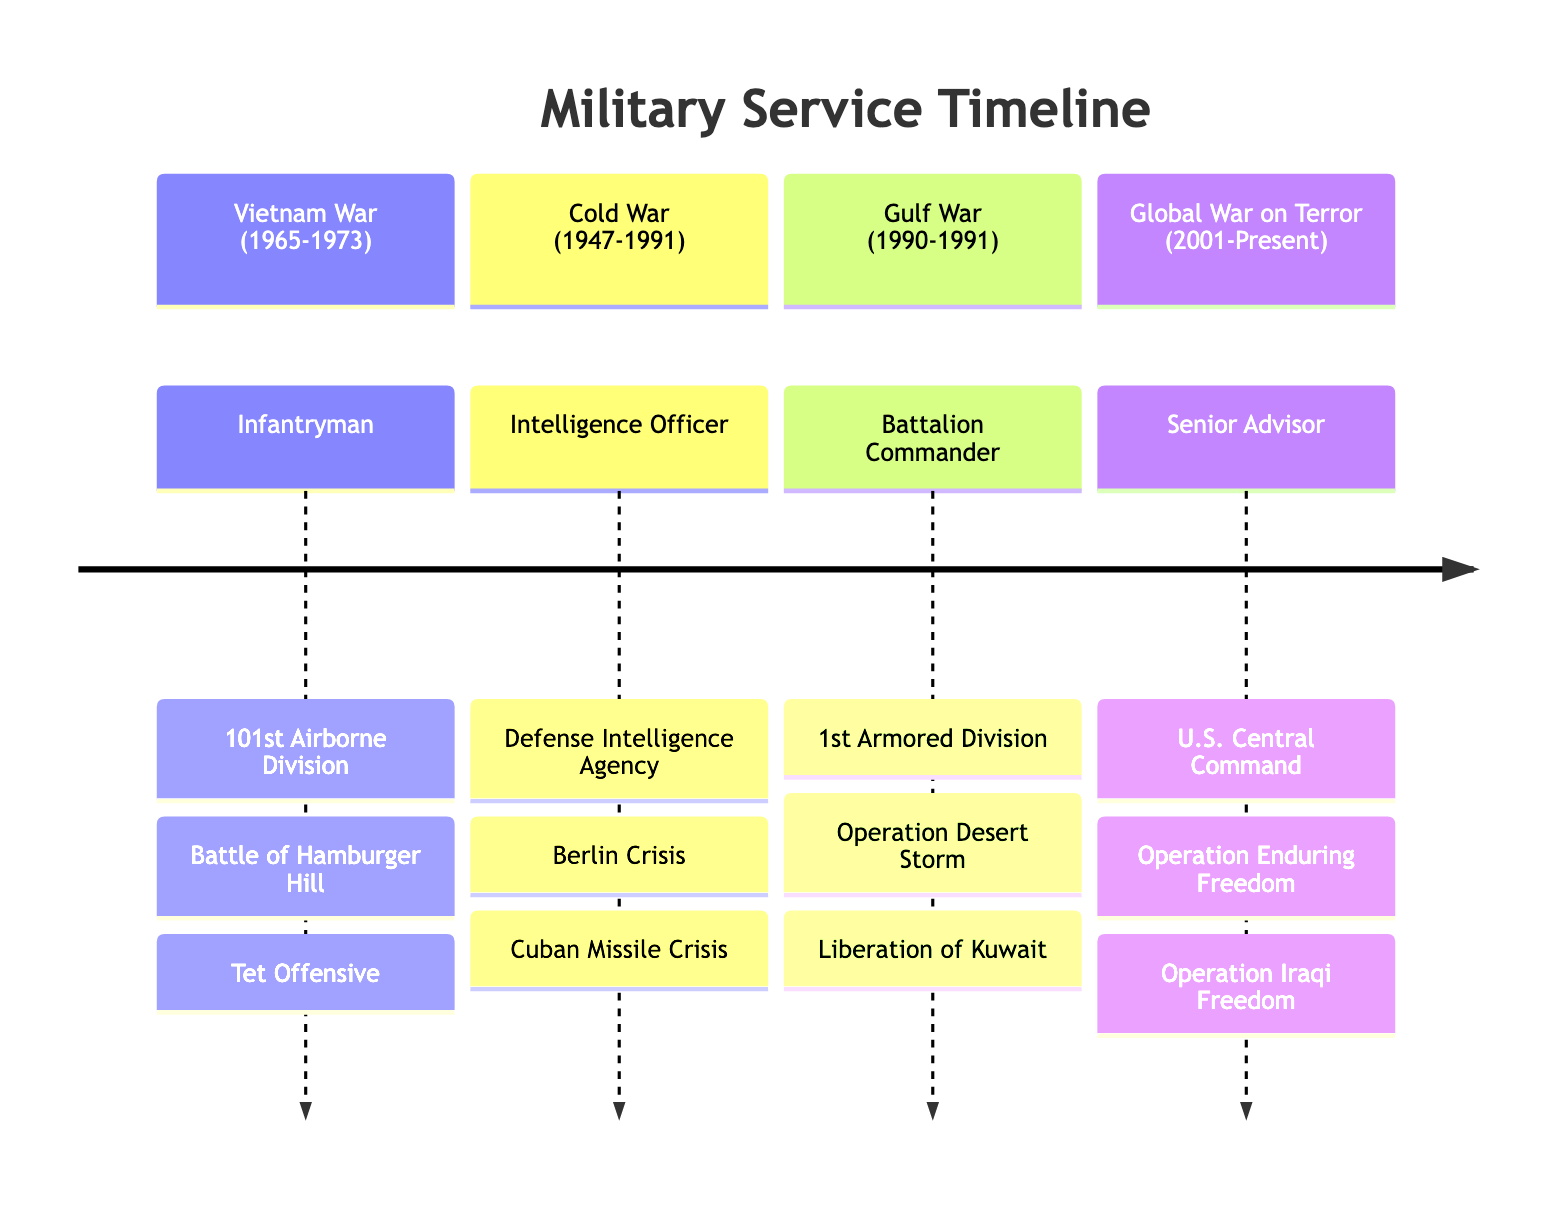What is the primary role during the Gulf War? The primary role listed during the Gulf War is "Battalion Commander". This can be found by looking under the Gulf War section of the diagram, where it specifies the personal service details for that conflict.
Answer: Battalion Commander How many major battles are listed for the Vietnam War? In the Vietnam War section, there are two major battles mentioned: the Battle of Hamburger Hill and the Tet Offensive. Therefore, by counting the battles listed, the answer is two.
Answer: 2 Which unit was involved in the Cold War? The unit specified for service during the Cold War is the "Defense Intelligence Agency". This can be determined from the Cold War section where the personal service details are provided.
Answer: Defense Intelligence Agency What major operation took place during the Gulf War? The major operations described under the Gulf War are "Operation Desert Storm" and "Liberation of Kuwait". Referencing the Gulf War section reveals this information.
Answer: Operation Desert Storm Who served as a Senior Advisor during the Global War on Terror? The individual who served as a Senior Advisor is identified in the Global War on Terror section, where it clearly states the role and the associated unit, which is U.S. Central Command.
Answer: U.S. Central Command Which two major crises are associated with the Cold War? The Cold War section cites the "Berlin Crisis" and "Cuban Missile Crisis" as key operations. To answer this question, one checks the operations listed in that section.
Answer: Berlin Crisis, Cuban Missile Crisis What was the starting year of the Vietnam War? The starting year of the Vietnam War, as shown in the diagram under the Vietnam War section, is 1965. This is explicitly stated when observing the timeline for that conflict.
Answer: 1965 What is the duration of the Gulf War? The duration of the Gulf War, according to the timeline in the Gulf War section, is from August 1990 to February 1991, which is a span of 6 months.
Answer: 6 months 